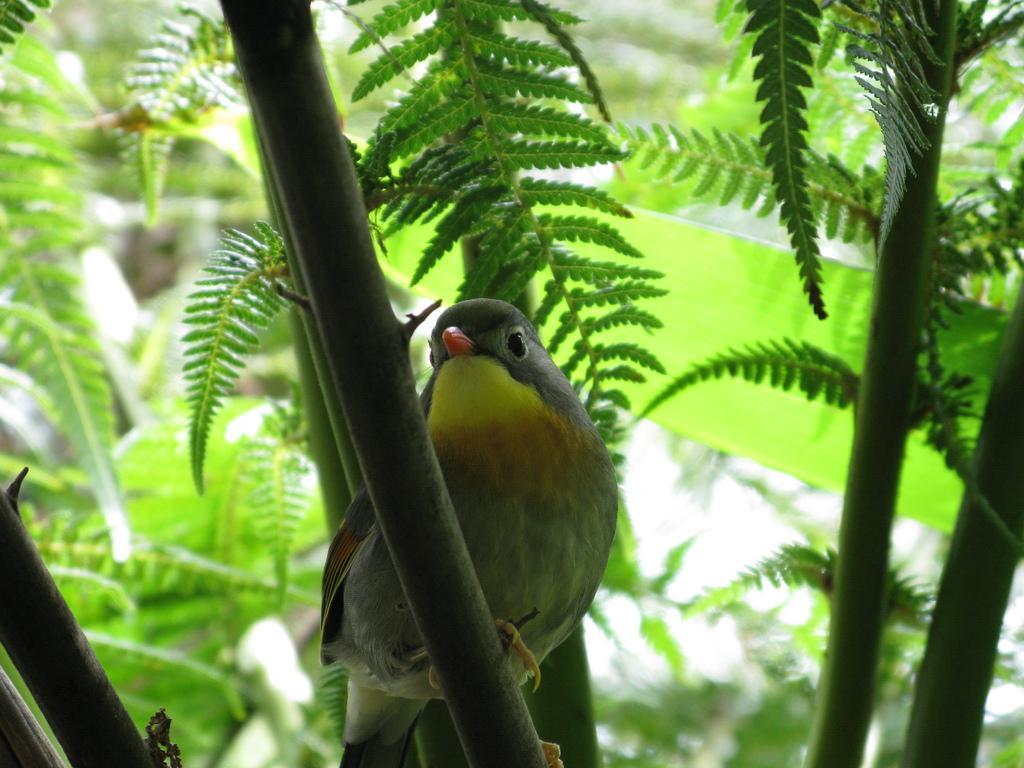How would you summarize this image in a sentence or two? This seems to be a macro photography of a bird sitting on a tree branch. 